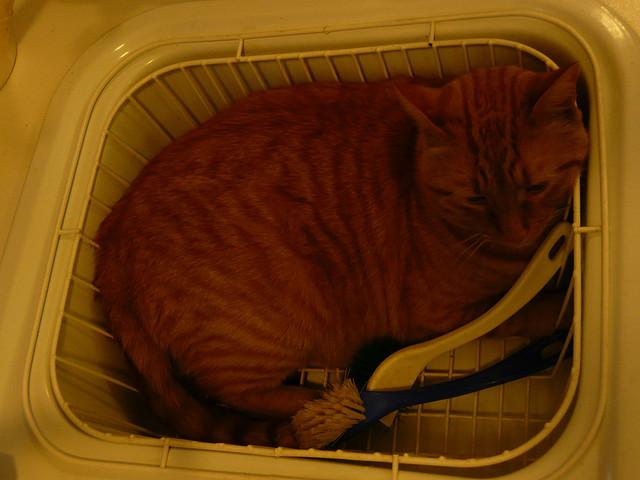Is the animal sleeping?
Answer briefly. No. What color is this cat?
Keep it brief. Orange. Where is the cat?
Quick response, please. Sink. 